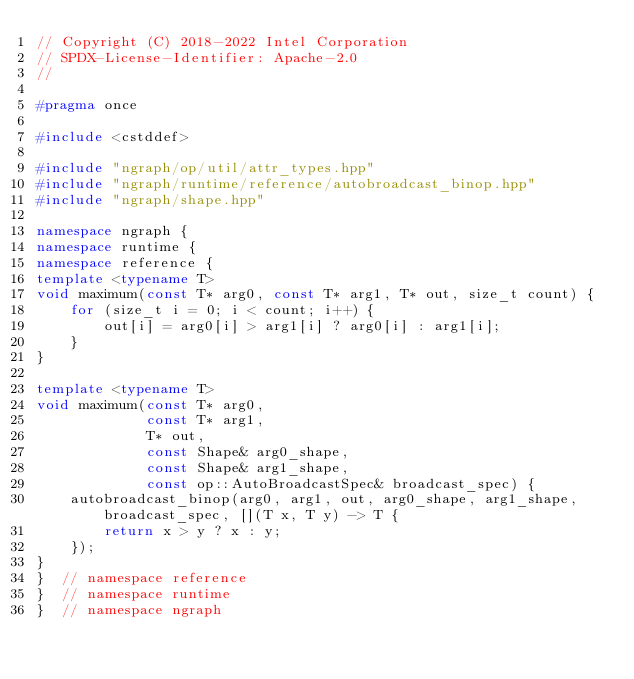<code> <loc_0><loc_0><loc_500><loc_500><_C++_>// Copyright (C) 2018-2022 Intel Corporation
// SPDX-License-Identifier: Apache-2.0
//

#pragma once

#include <cstddef>

#include "ngraph/op/util/attr_types.hpp"
#include "ngraph/runtime/reference/autobroadcast_binop.hpp"
#include "ngraph/shape.hpp"

namespace ngraph {
namespace runtime {
namespace reference {
template <typename T>
void maximum(const T* arg0, const T* arg1, T* out, size_t count) {
    for (size_t i = 0; i < count; i++) {
        out[i] = arg0[i] > arg1[i] ? arg0[i] : arg1[i];
    }
}

template <typename T>
void maximum(const T* arg0,
             const T* arg1,
             T* out,
             const Shape& arg0_shape,
             const Shape& arg1_shape,
             const op::AutoBroadcastSpec& broadcast_spec) {
    autobroadcast_binop(arg0, arg1, out, arg0_shape, arg1_shape, broadcast_spec, [](T x, T y) -> T {
        return x > y ? x : y;
    });
}
}  // namespace reference
}  // namespace runtime
}  // namespace ngraph
</code> 